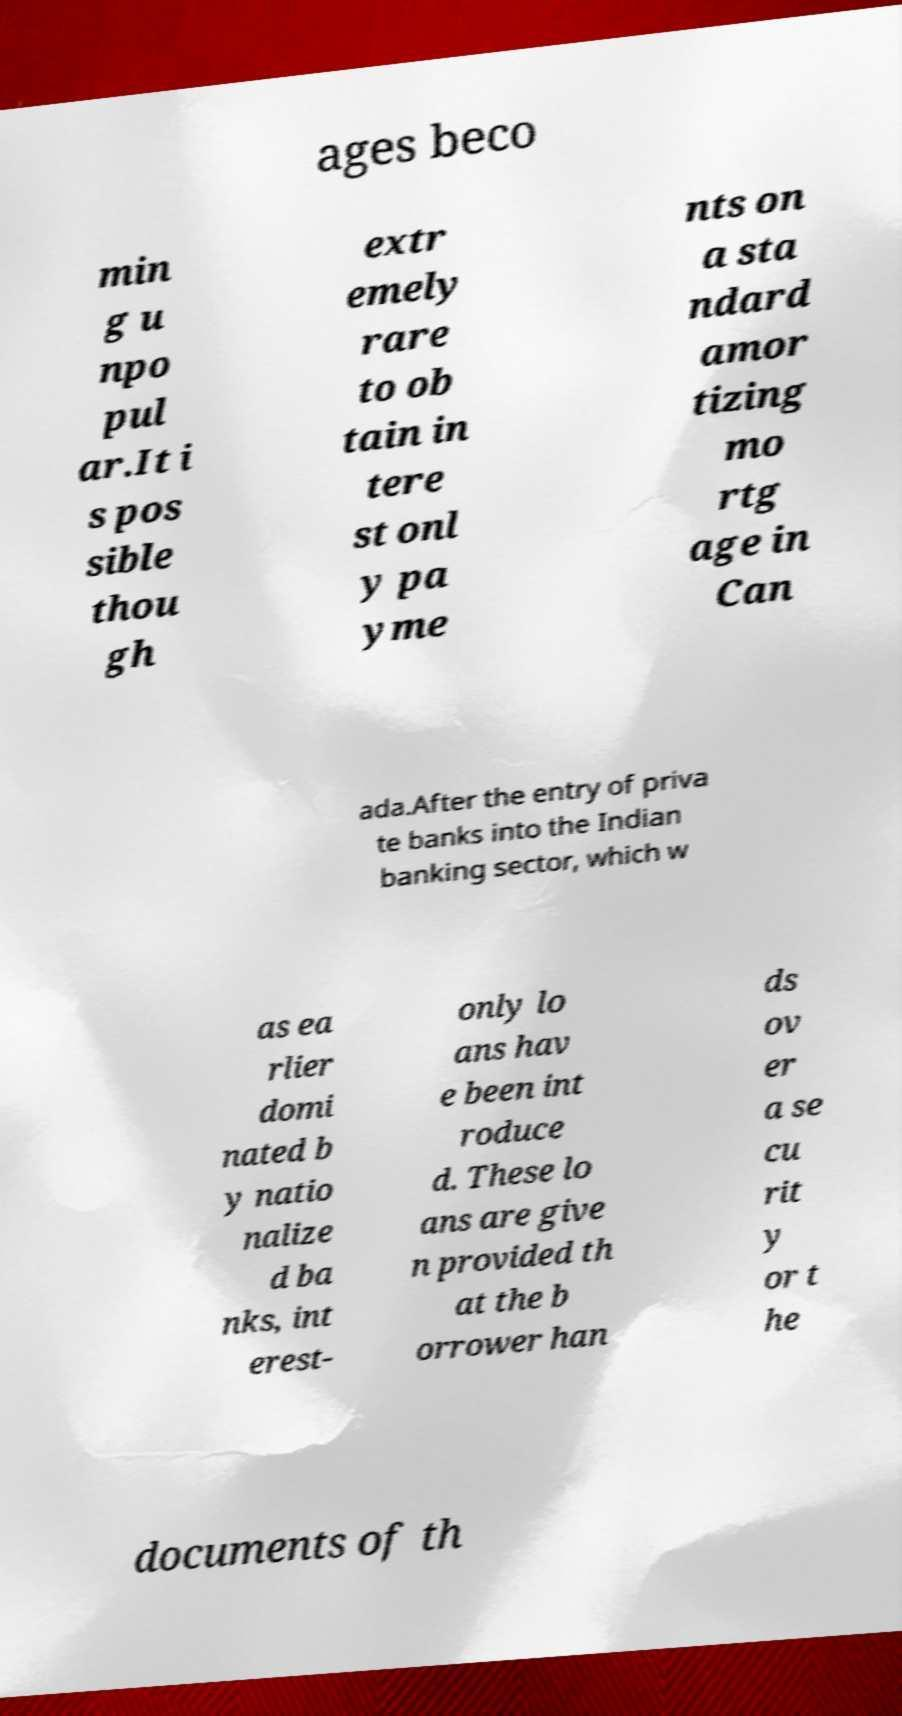Could you assist in decoding the text presented in this image and type it out clearly? ages beco min g u npo pul ar.It i s pos sible thou gh extr emely rare to ob tain in tere st onl y pa yme nts on a sta ndard amor tizing mo rtg age in Can ada.After the entry of priva te banks into the Indian banking sector, which w as ea rlier domi nated b y natio nalize d ba nks, int erest- only lo ans hav e been int roduce d. These lo ans are give n provided th at the b orrower han ds ov er a se cu rit y or t he documents of th 